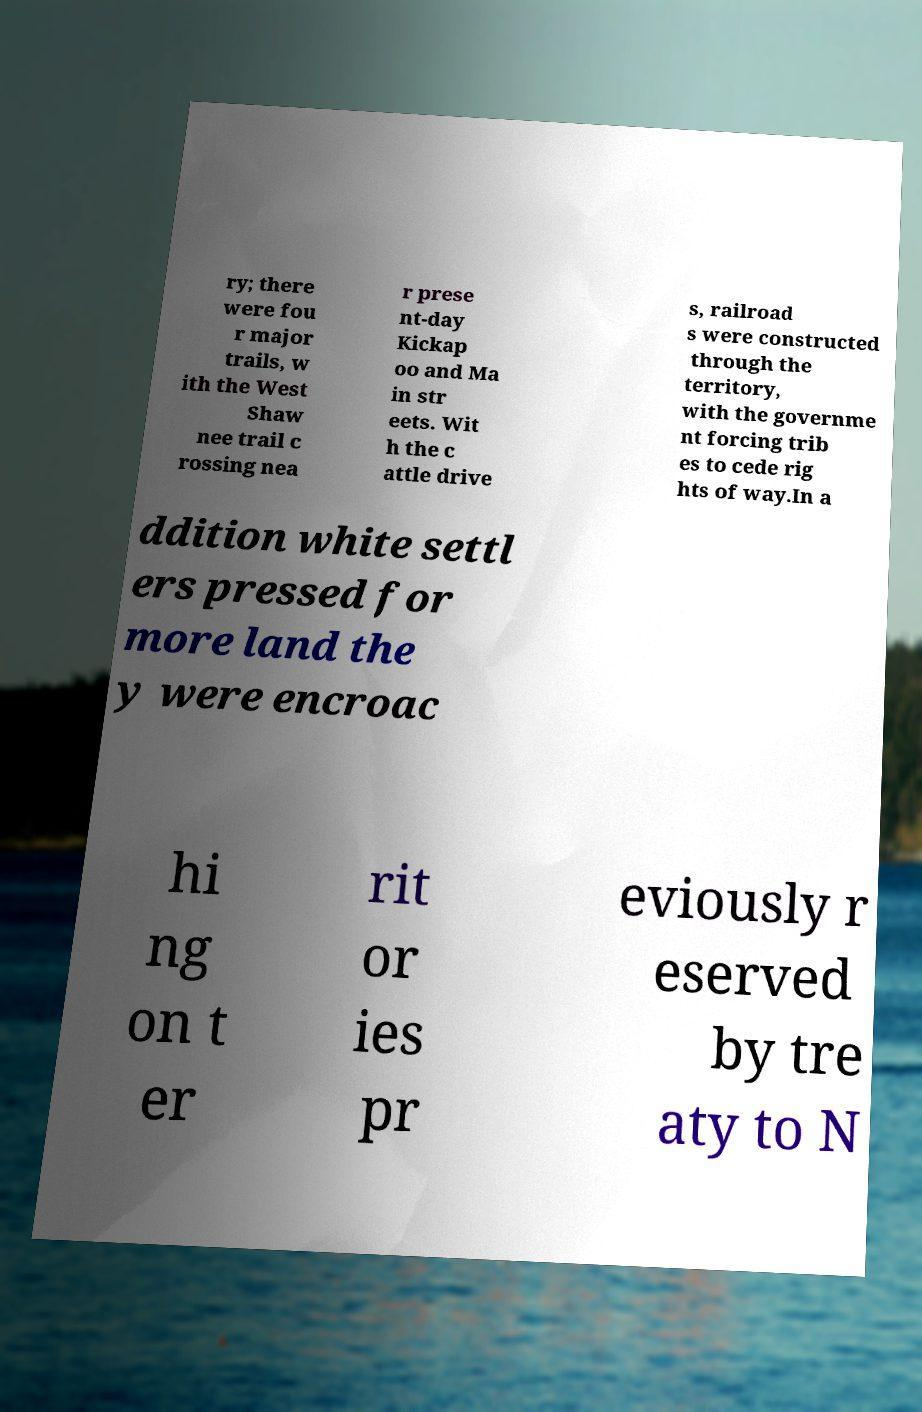Can you accurately transcribe the text from the provided image for me? ry; there were fou r major trails, w ith the West Shaw nee trail c rossing nea r prese nt-day Kickap oo and Ma in str eets. Wit h the c attle drive s, railroad s were constructed through the territory, with the governme nt forcing trib es to cede rig hts of way.In a ddition white settl ers pressed for more land the y were encroac hi ng on t er rit or ies pr eviously r eserved by tre aty to N 